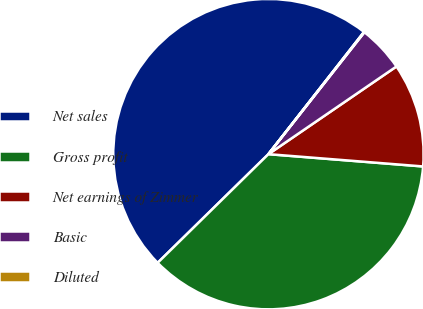Convert chart. <chart><loc_0><loc_0><loc_500><loc_500><pie_chart><fcel>Net sales<fcel>Gross profit<fcel>Net earnings of Zimmer<fcel>Basic<fcel>Diluted<nl><fcel>47.91%<fcel>36.39%<fcel>10.82%<fcel>4.83%<fcel>0.05%<nl></chart> 